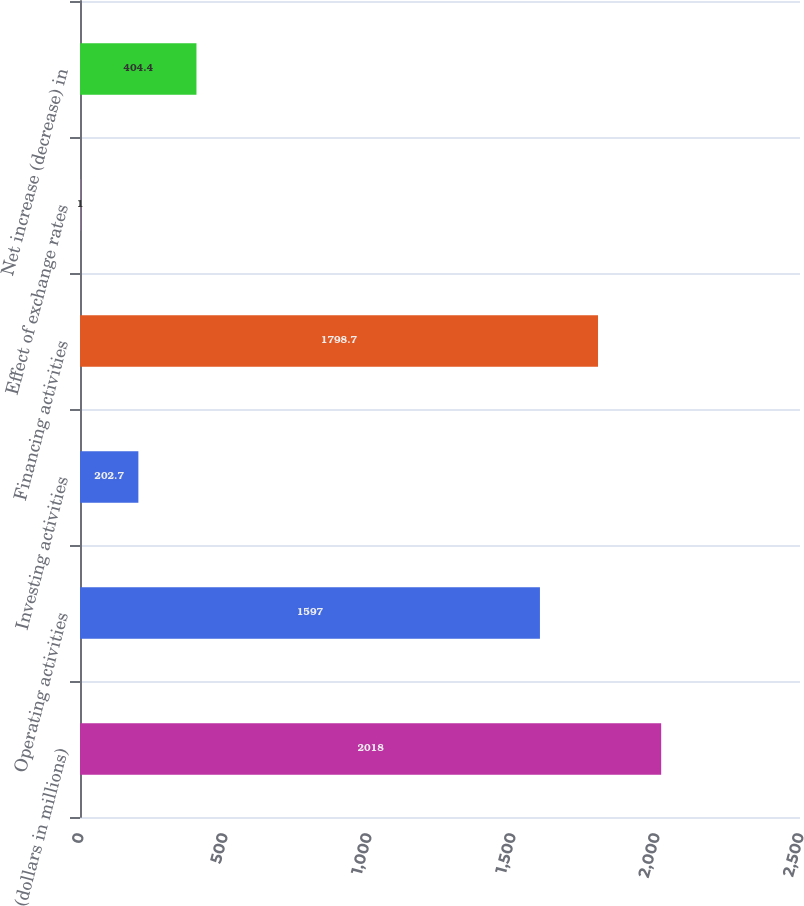Convert chart. <chart><loc_0><loc_0><loc_500><loc_500><bar_chart><fcel>(dollars in millions)<fcel>Operating activities<fcel>Investing activities<fcel>Financing activities<fcel>Effect of exchange rates<fcel>Net increase (decrease) in<nl><fcel>2018<fcel>1597<fcel>202.7<fcel>1798.7<fcel>1<fcel>404.4<nl></chart> 